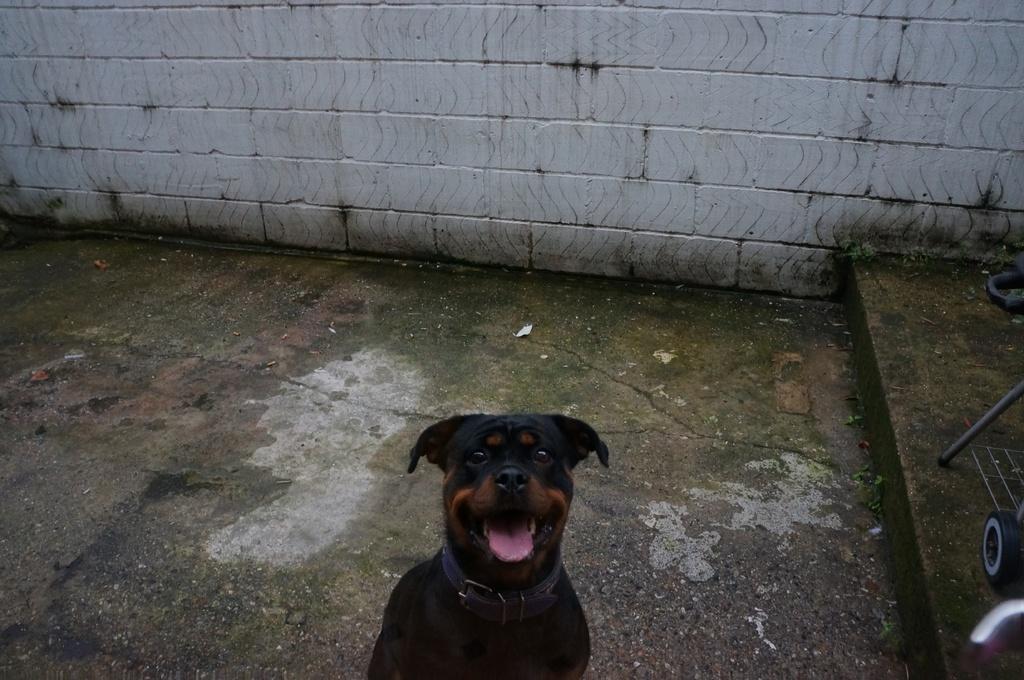Could you give a brief overview of what you see in this image? This image is taken outdoors. At the bottom of the image there is a floor. In the background there is a wall. On the right side of the image there is an object on the floor. In the middle of the image there is a dog. 